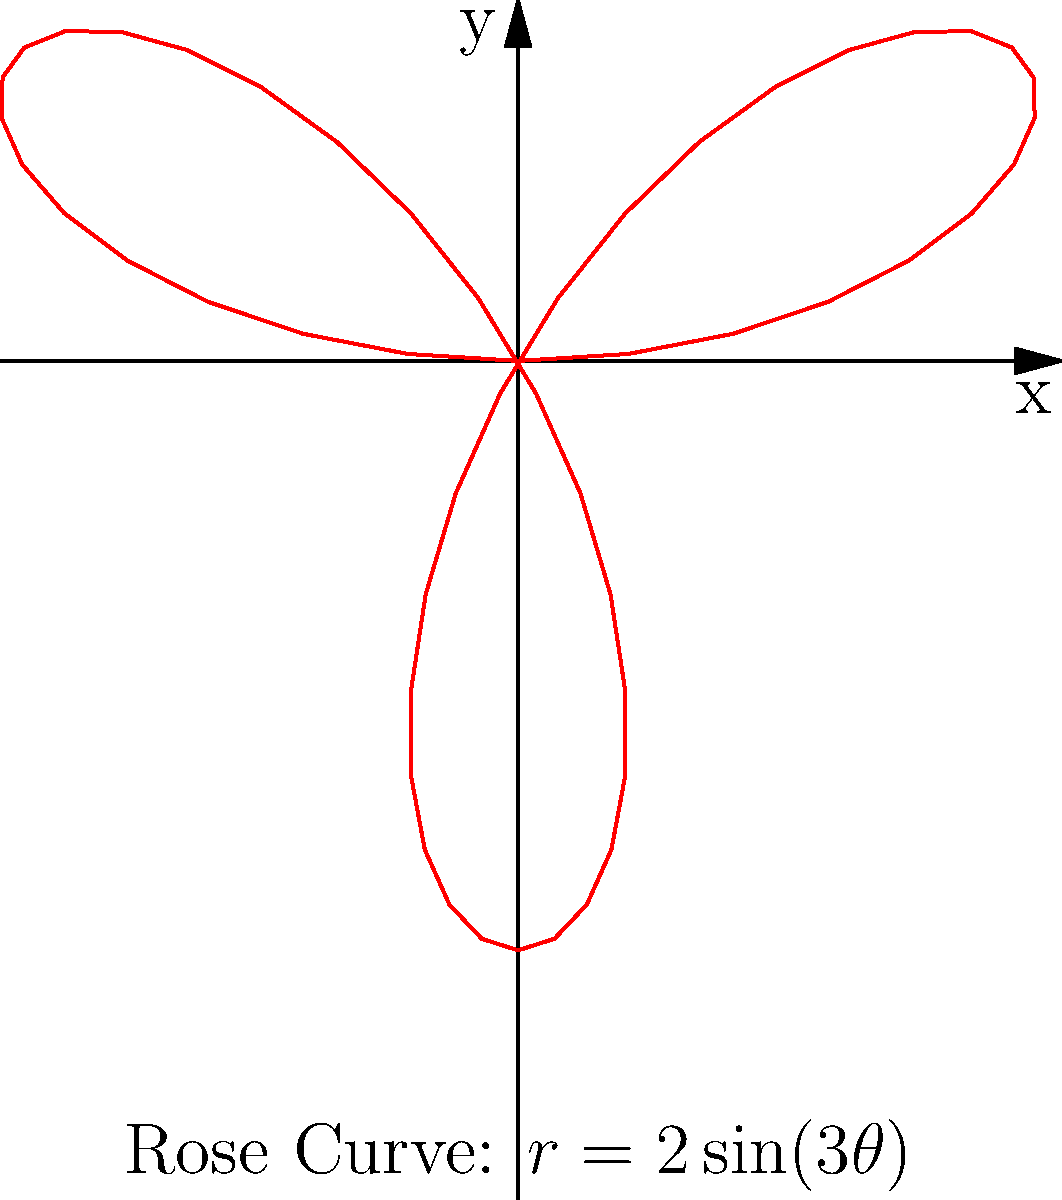In the context of floral-inspired hairstyles, how many petals does the rose curve $r=2\sin(3\theta)$ have, and how might this pattern inspire a unique hairstyle for a student expressing their creativity? To determine the number of petals in the rose curve $r=2\sin(3\theta)$, we need to follow these steps:

1. Identify the general form of a rose curve: $r = a \sin(n\theta)$ or $r = a \cos(n\theta)$
2. In our case, $r=2\sin(3\theta)$, so $a=2$ and $n=3$
3. The number of petals in a rose curve is determined by $n$:
   - If $n$ is odd, the number of petals is $n$
   - If $n$ is even, the number of petals is $2n$
4. Since $n=3$, which is odd, the number of petals is 3

For a floral-inspired hairstyle, this three-petal pattern could inspire:
1. A triple braid crown resembling the three-petal structure
2. Three distinct sections of hair styled to mimic the curve's lobes
3. A hair accessory or clip designed with a three-petal motif

This hairstyle would allow a student to express their creativity by incorporating mathematical concepts into their appearance, fostering a connection between abstract ideas and personal expression.
Answer: 3 petals 